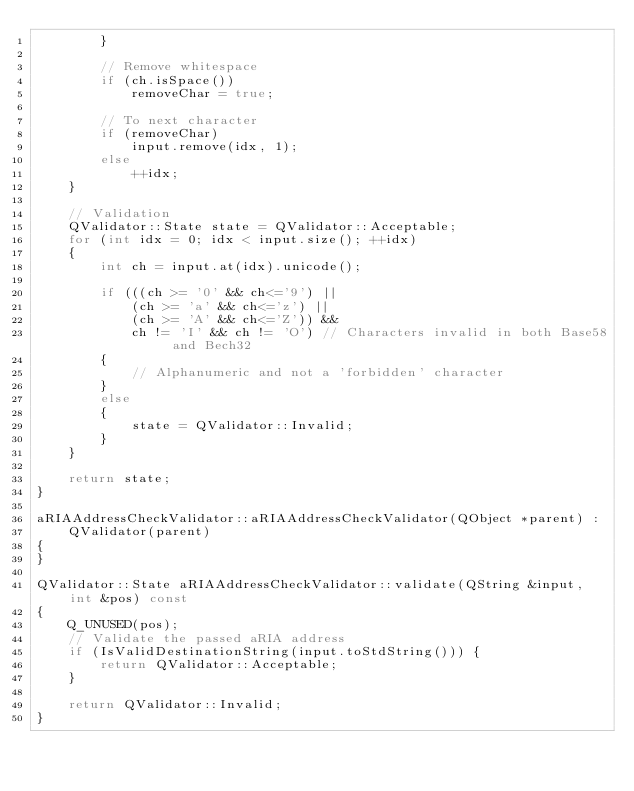Convert code to text. <code><loc_0><loc_0><loc_500><loc_500><_C++_>        }

        // Remove whitespace
        if (ch.isSpace())
            removeChar = true;

        // To next character
        if (removeChar)
            input.remove(idx, 1);
        else
            ++idx;
    }

    // Validation
    QValidator::State state = QValidator::Acceptable;
    for (int idx = 0; idx < input.size(); ++idx)
    {
        int ch = input.at(idx).unicode();

        if (((ch >= '0' && ch<='9') ||
            (ch >= 'a' && ch<='z') ||
            (ch >= 'A' && ch<='Z')) &&
            ch != 'I' && ch != 'O') // Characters invalid in both Base58 and Bech32
        {
            // Alphanumeric and not a 'forbidden' character
        }
        else
        {
            state = QValidator::Invalid;
        }
    }

    return state;
}

aRIAAddressCheckValidator::aRIAAddressCheckValidator(QObject *parent) :
    QValidator(parent)
{
}

QValidator::State aRIAAddressCheckValidator::validate(QString &input, int &pos) const
{
    Q_UNUSED(pos);
    // Validate the passed aRIA address
    if (IsValidDestinationString(input.toStdString())) {
        return QValidator::Acceptable;
    }

    return QValidator::Invalid;
}
</code> 